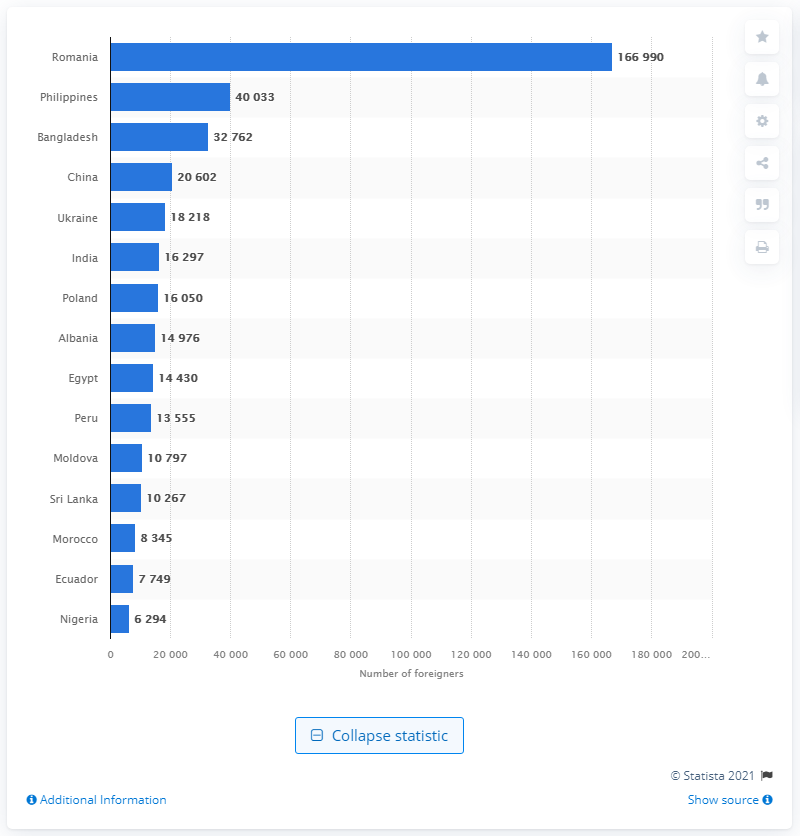Indicate a few pertinent items in this graphic. In 2019, there were approximately 40,033 Filipinos living in Rome. In 2019, the largest number of foreigners living in Rome came from Romania. In 2019, Romania had the largest number of foreign residents living in Rome. 